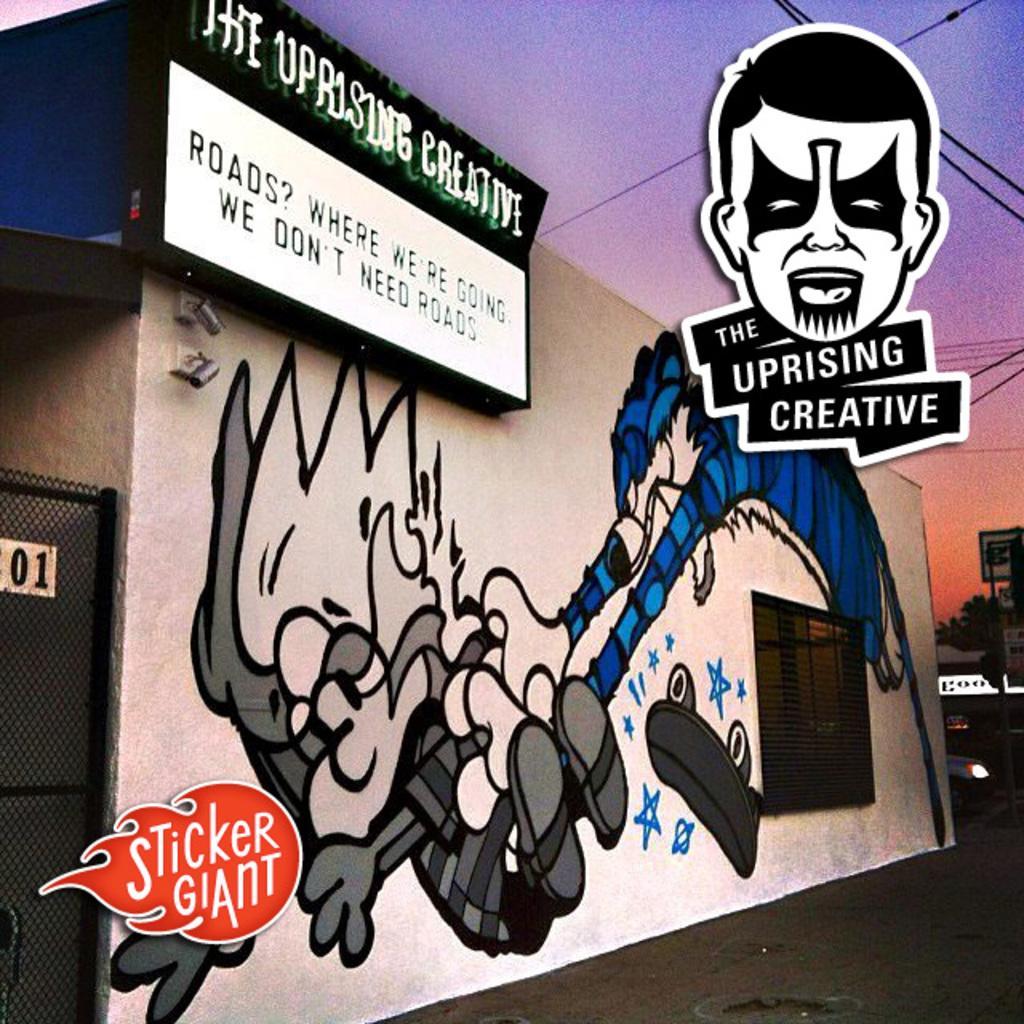Could you give a brief overview of what you see in this image? In this picture I can see the poster which showing a person who is kicking to another one which is painted on the wall. Beside that there is a window. On the left there is a black gate. In the background I can see the advertisement board, trees, buildings and cars. At the top I can see the sky and electric wires. In the top left corner I can see the banners. 